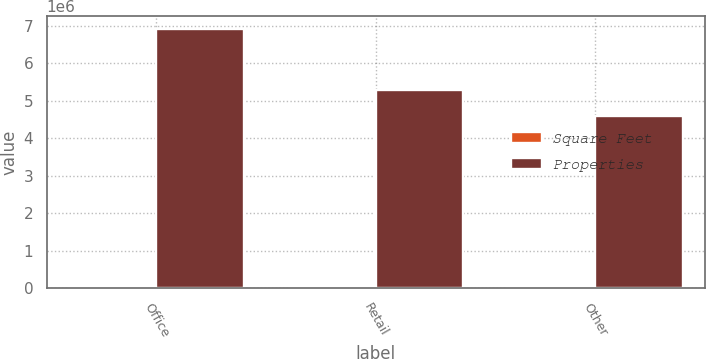Convert chart to OTSL. <chart><loc_0><loc_0><loc_500><loc_500><stacked_bar_chart><ecel><fcel>Office<fcel>Retail<fcel>Other<nl><fcel>Square Feet<fcel>36<fcel>148<fcel>19<nl><fcel>Properties<fcel>6.909e+06<fcel>5.274e+06<fcel>4.592e+06<nl></chart> 